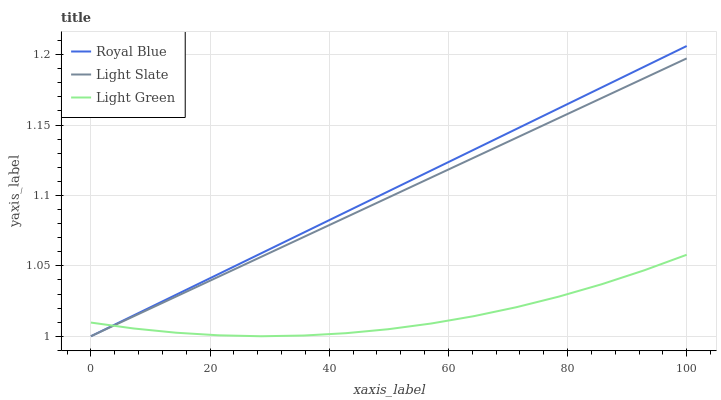Does Light Green have the minimum area under the curve?
Answer yes or no. Yes. Does Royal Blue have the maximum area under the curve?
Answer yes or no. Yes. Does Royal Blue have the minimum area under the curve?
Answer yes or no. No. Does Light Green have the maximum area under the curve?
Answer yes or no. No. Is Royal Blue the smoothest?
Answer yes or no. Yes. Is Light Green the roughest?
Answer yes or no. Yes. Is Light Green the smoothest?
Answer yes or no. No. Is Royal Blue the roughest?
Answer yes or no. No. Does Light Slate have the lowest value?
Answer yes or no. Yes. Does Light Green have the lowest value?
Answer yes or no. No. Does Royal Blue have the highest value?
Answer yes or no. Yes. Does Light Green have the highest value?
Answer yes or no. No. Does Royal Blue intersect Light Green?
Answer yes or no. Yes. Is Royal Blue less than Light Green?
Answer yes or no. No. Is Royal Blue greater than Light Green?
Answer yes or no. No. 